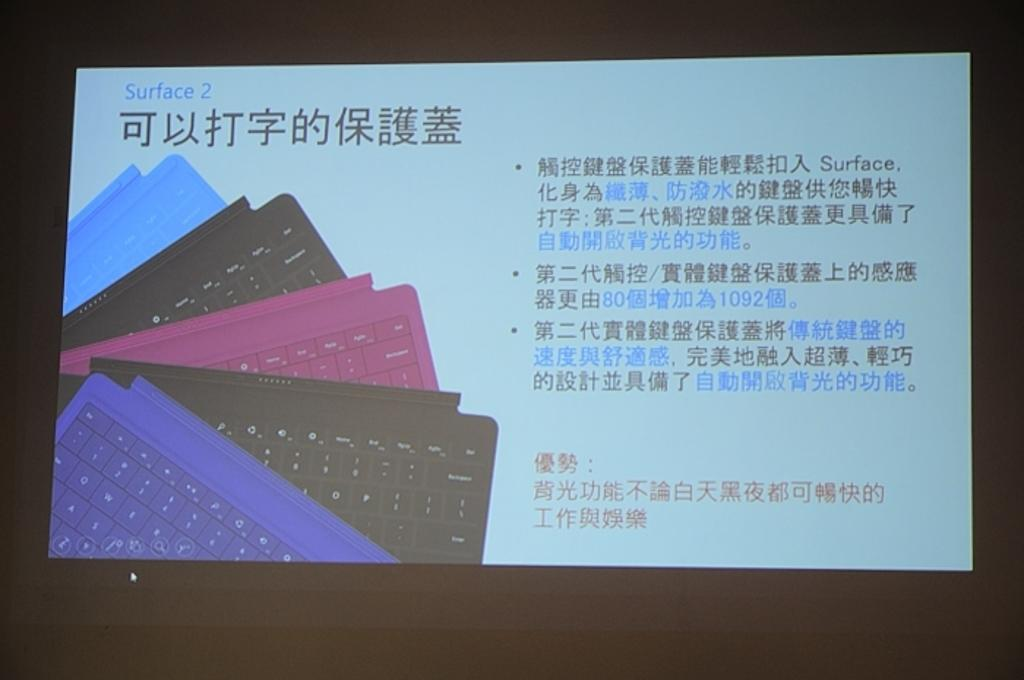<image>
Create a compact narrative representing the image presented. a screen that has different colored keyboards on it and the words 'surface 2' on the top left corner 